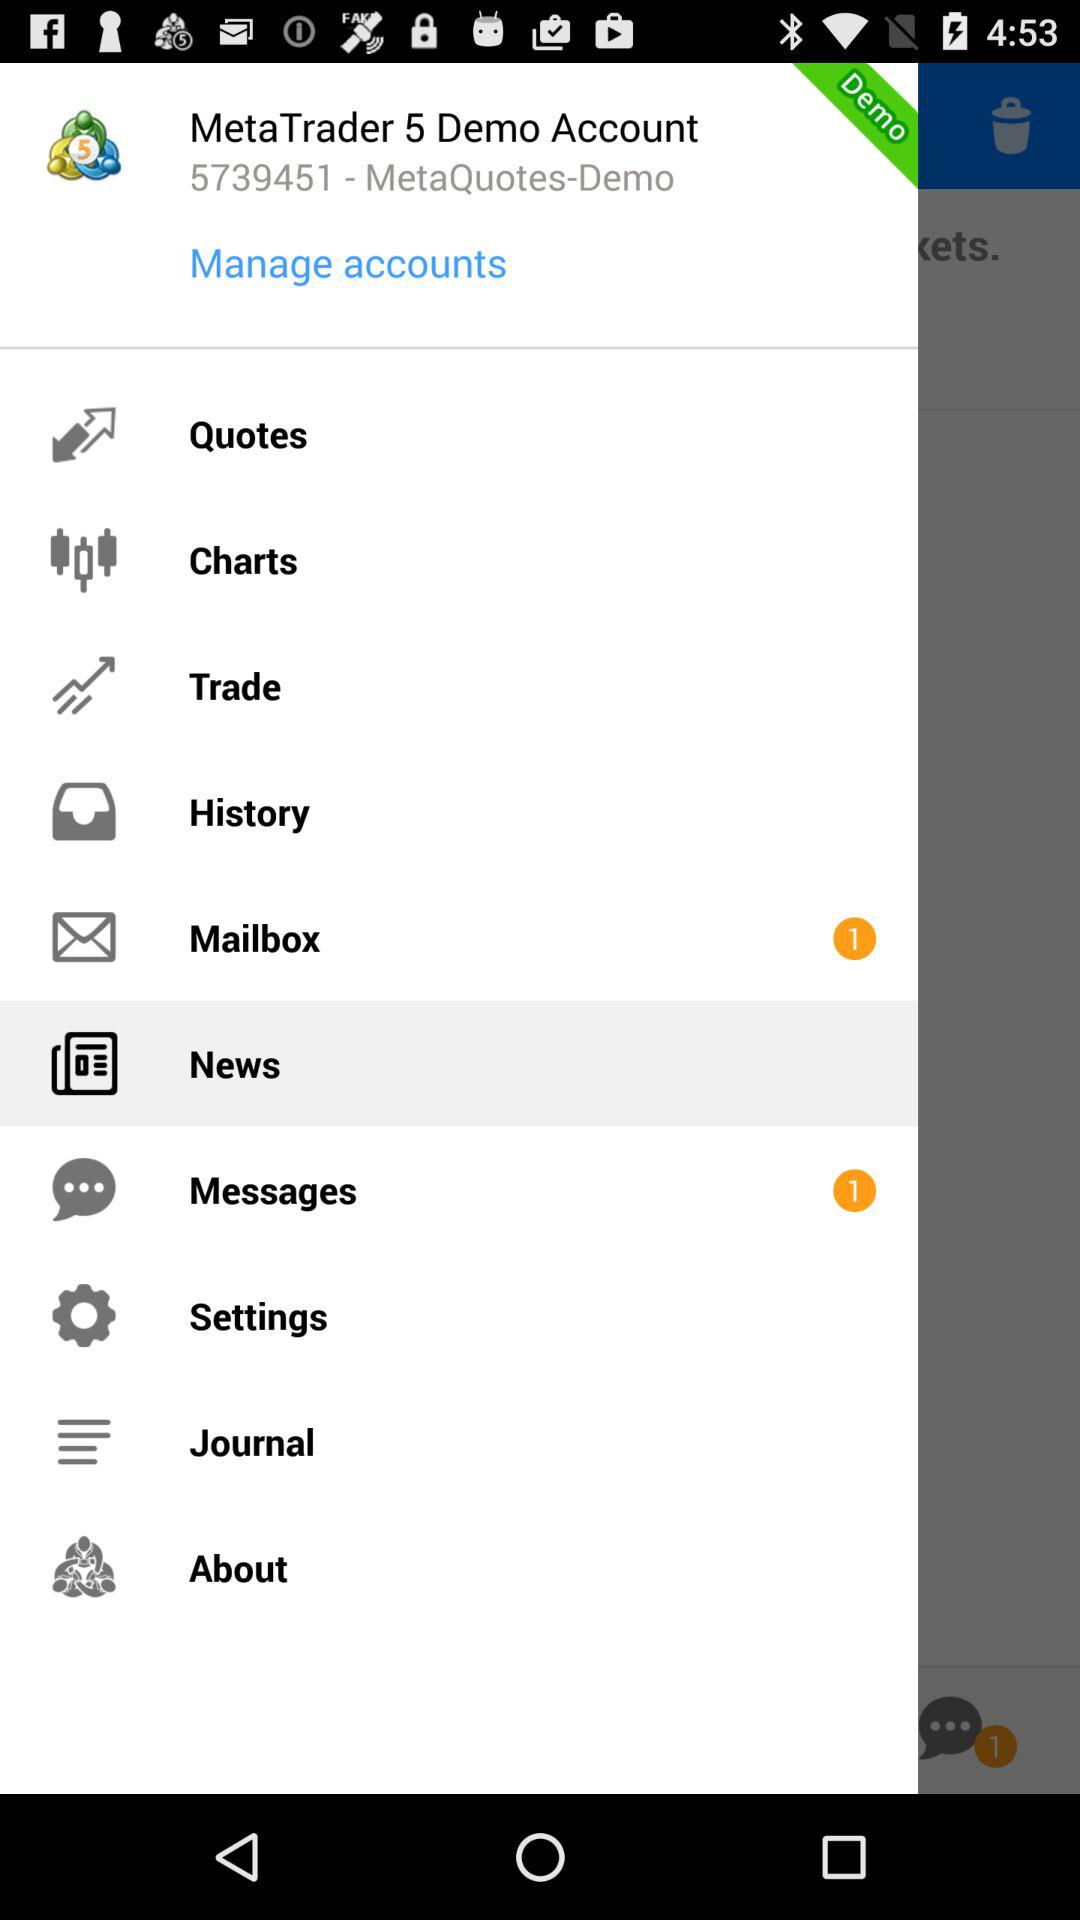How many messages are in the messaging app? There is only 1 message. 